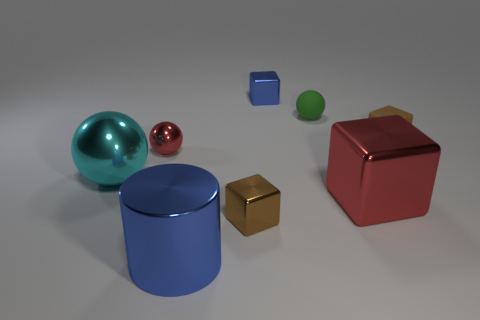Subtract all large red metal blocks. How many blocks are left? 3 Subtract all red cubes. How many cubes are left? 3 Subtract all cyan blocks. Subtract all red spheres. How many blocks are left? 4 Add 1 large purple matte balls. How many objects exist? 9 Subtract all balls. How many objects are left? 5 Add 5 large blue matte things. How many large blue matte things exist? 5 Subtract 0 yellow blocks. How many objects are left? 8 Subtract all tiny blue spheres. Subtract all small matte spheres. How many objects are left? 7 Add 7 large blocks. How many large blocks are left? 8 